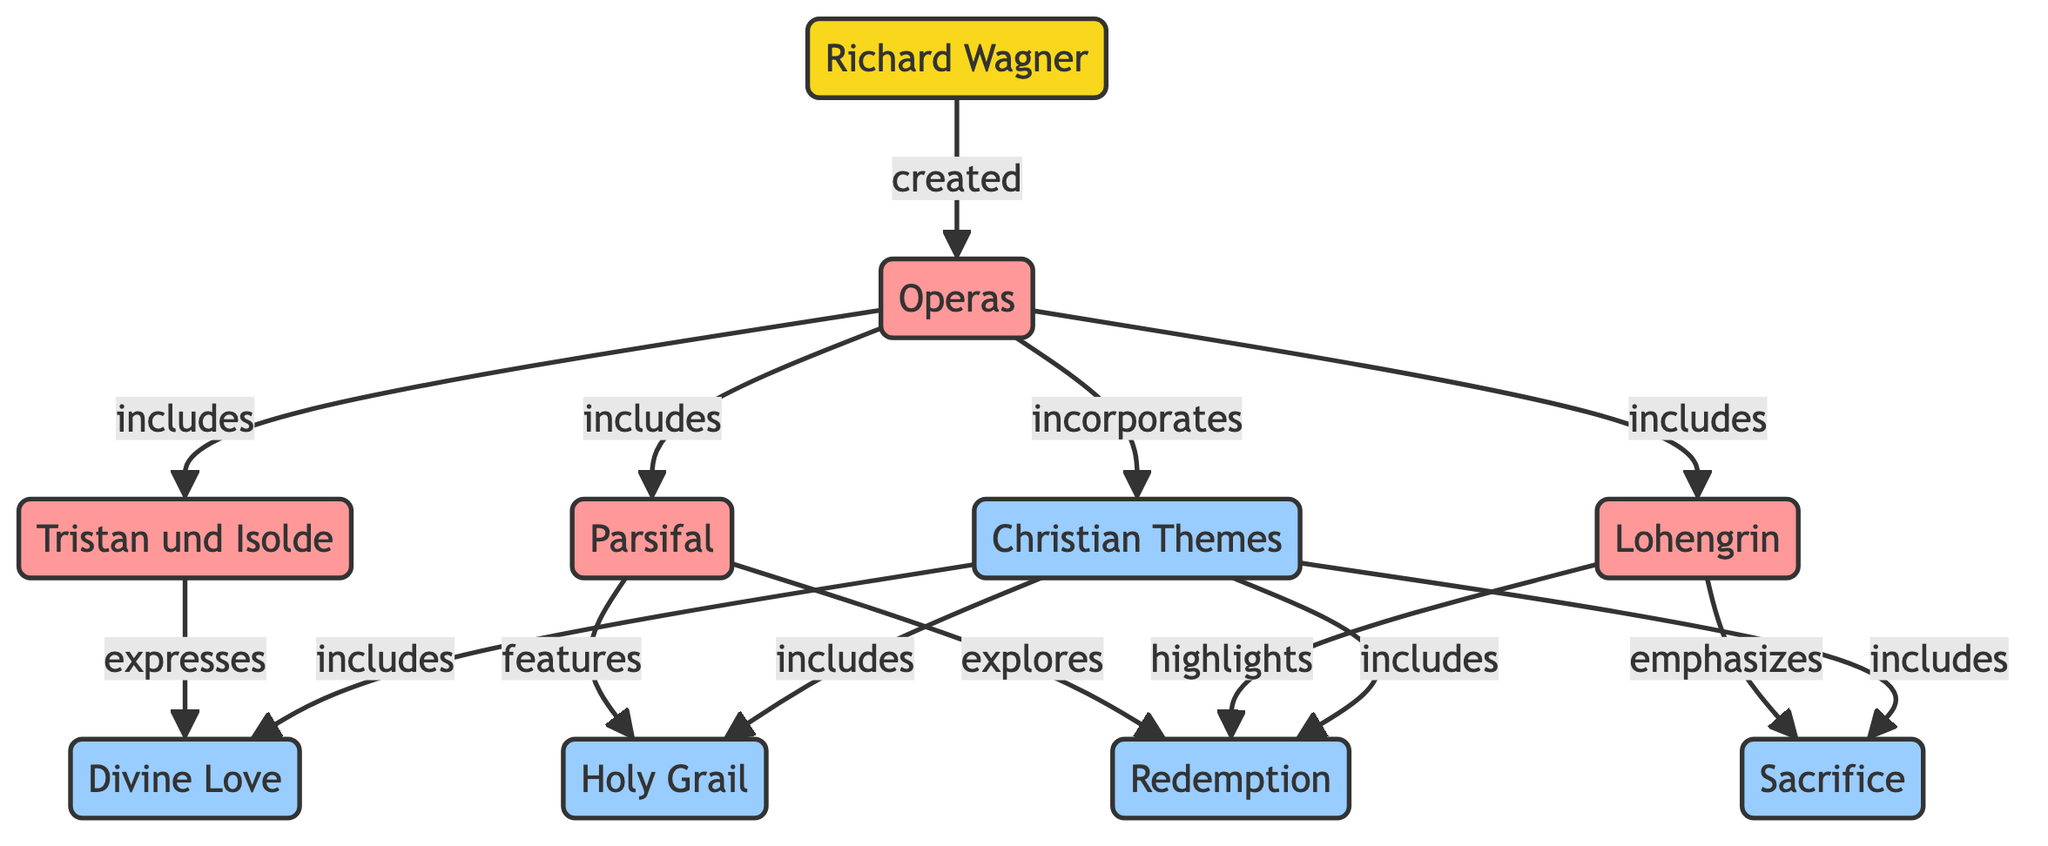What is the total number of nodes in the diagram? By counting the distinct entities represented in the diagram, we can find that there are a total of 10 unique nodes: Wagner, Operas, Tristan und Isolde, Parsifal, Lohengrin, Christian Themes, Redemption, Holy Grail, Sacrifice, and Love.
Answer: 10 Which opera emphasizes Sacrifice? By tracing the edges in the diagram, we can see that Lohengrin has a directed edge leading to Sacrifice with the label "emphasizes." This indicates that the work itself highlights the theme of Sacrifice.
Answer: Lohengrin What relationship exists between Tristan und Isolde and Divine Love? There is a directed edge from Tristan und Isolde to Love with the label "expresses." This shows that Tristan und Isolde conveys or represents the theme of Divine Love.
Answer: expresses Which opera includes the theme of the Holy Grail? Looking at the nodes and edges, we find that the opera Parsifal features a direct connection to the Holy Grail, as indicated by the labeled edge "features."
Answer: Parsifal How many Christian themes are included in the diagram? By examining the connections from the Christian Themes node to its associated themes, we see it includes four themes: Love, Redemption, Holy Grail, and Sacrifice. Counting these edges gives us the total.
Answer: 4 What is the primary function of the Operas node in this diagram? The Operas node serves as a central connecting point that links Richard Wagner to his specific operas and also shows that these operas incorporate Christian Themes. Therefore, its primary function is to represent Wagner’s body of work and its thematic connections.
Answer: incorporates Which of Wagner's operas explores Redemption? From the edges connected to the operas, Parsifal and Lohengrin both have labels that indicate they explore or highlight the theme of Redemption. Therefore, both can be identified in response to the question.
Answer: Parsifal, Lohengrin How does the Love theme relate to Christian Themes? We see from the diagram that Love has a directed edge going from Christian Themes to Love, indicating that Love is included as a category under Christian Themes.
Answer: includes Which two themes are directly connected to the opera Parsifal in the diagram? By inspecting the edges from Parsifal, we find that Holy Grail and Redemption are the two themes that connect directly to this opera, with edges labeled "features" and "explores," respectively.
Answer: Holy Grail, Redemption 